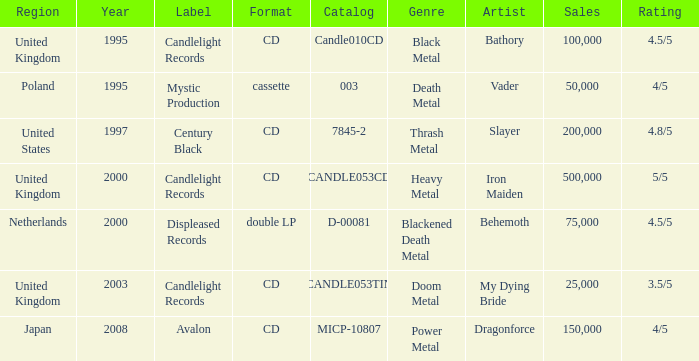What year did Japan form a label? 2008.0. 